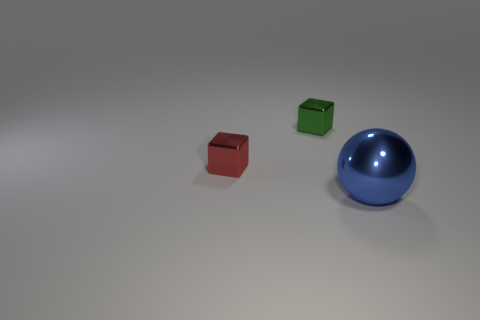What number of other objects are there of the same size as the sphere?
Your answer should be compact. 0. How many things are either things that are behind the metal sphere or green things?
Provide a short and direct response. 2. Are there the same number of small green metal things on the left side of the ball and small metallic blocks behind the green shiny object?
Offer a very short reply. No. The tiny cube that is behind the cube that is in front of the block that is to the right of the tiny red metallic cube is made of what material?
Ensure brevity in your answer.  Metal. There is a thing that is both left of the metallic ball and right of the tiny red thing; what is its size?
Your response must be concise. Small. Is the small green metallic thing the same shape as the big thing?
Your answer should be compact. No. There is a red object that is made of the same material as the tiny green thing; what is its shape?
Your answer should be compact. Cube. What number of small things are either cyan shiny cylinders or green shiny cubes?
Give a very brief answer. 1. Are there any shiny things to the right of the tiny red cube left of the tiny green metal thing?
Keep it short and to the point. Yes. Are any large metal cylinders visible?
Provide a succinct answer. No. 